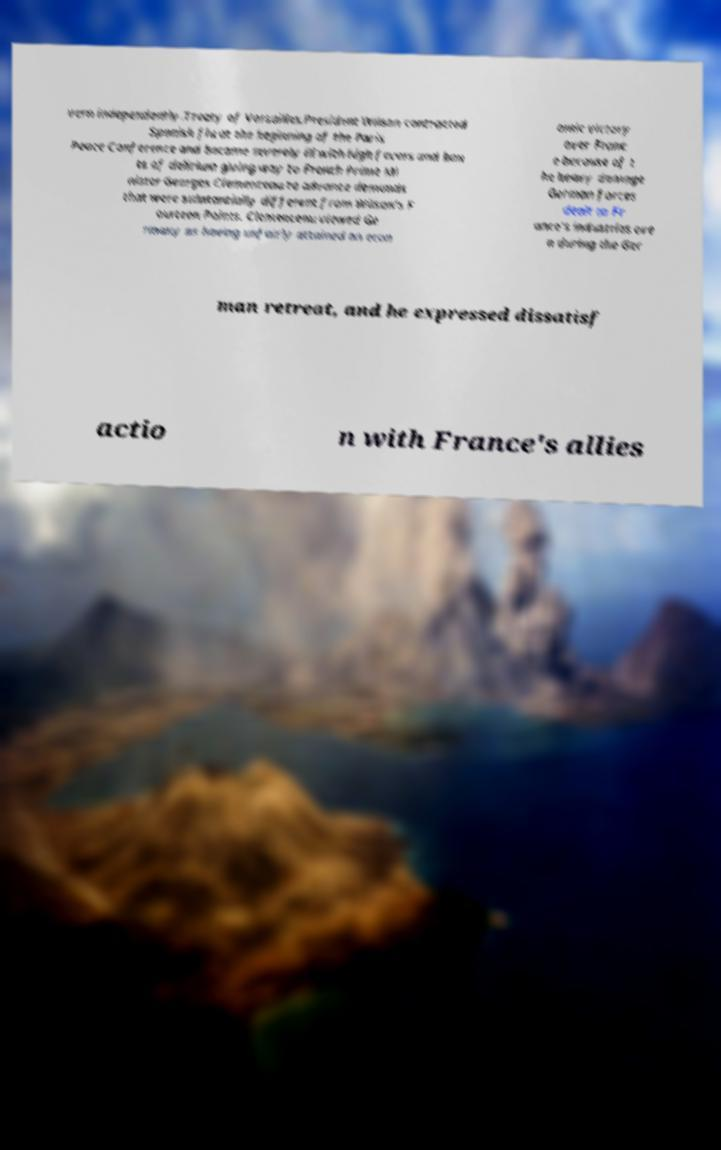There's text embedded in this image that I need extracted. Can you transcribe it verbatim? vern independently.Treaty of Versailles.President Wilson contracted Spanish flu at the beginning of the Paris Peace Conference and became severely ill with high fevers and bou ts of delirium giving way to French Prime Mi nister Georges Clemenceau to advance demands that were substantially different from Wilson's F ourteen Points. Clemenceau viewed Ge rmany as having unfairly attained an econ omic victory over Franc e because of t he heavy damage German forces dealt to Fr ance's industries eve n during the Ger man retreat, and he expressed dissatisf actio n with France's allies 